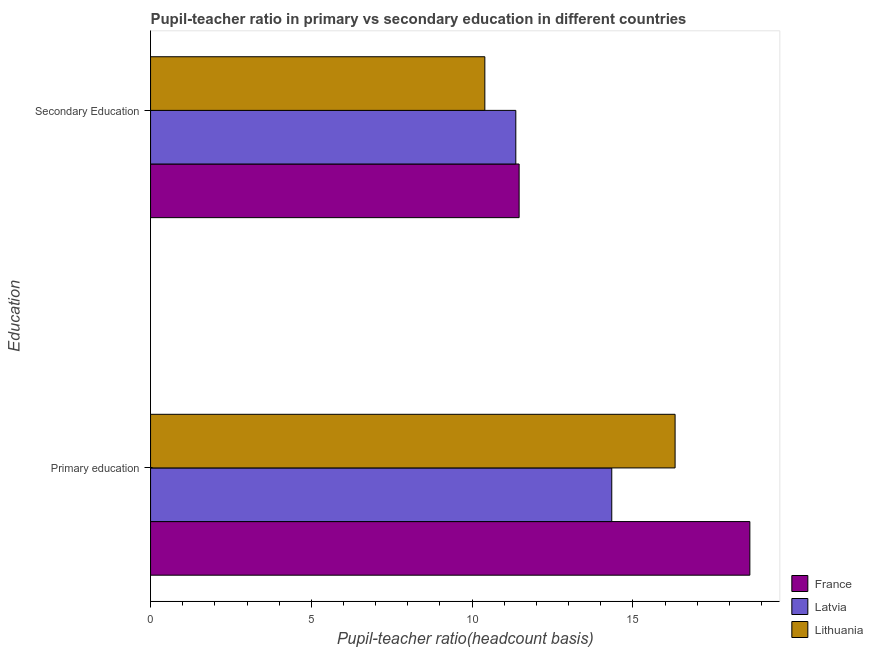How many different coloured bars are there?
Your answer should be compact. 3. Are the number of bars per tick equal to the number of legend labels?
Your answer should be compact. Yes. Are the number of bars on each tick of the Y-axis equal?
Your response must be concise. Yes. What is the label of the 1st group of bars from the top?
Provide a short and direct response. Secondary Education. What is the pupil-teacher ratio in primary education in France?
Offer a very short reply. 18.64. Across all countries, what is the maximum pupil-teacher ratio in primary education?
Provide a succinct answer. 18.64. Across all countries, what is the minimum pupil teacher ratio on secondary education?
Keep it short and to the point. 10.4. In which country was the pupil teacher ratio on secondary education maximum?
Keep it short and to the point. France. In which country was the pupil teacher ratio on secondary education minimum?
Your response must be concise. Lithuania. What is the total pupil-teacher ratio in primary education in the graph?
Your response must be concise. 49.3. What is the difference between the pupil-teacher ratio in primary education in France and that in Lithuania?
Give a very brief answer. 2.33. What is the difference between the pupil teacher ratio on secondary education in France and the pupil-teacher ratio in primary education in Lithuania?
Make the answer very short. -4.85. What is the average pupil-teacher ratio in primary education per country?
Your answer should be compact. 16.43. What is the difference between the pupil teacher ratio on secondary education and pupil-teacher ratio in primary education in Latvia?
Offer a very short reply. -2.98. In how many countries, is the pupil-teacher ratio in primary education greater than 4 ?
Offer a very short reply. 3. What is the ratio of the pupil-teacher ratio in primary education in Lithuania to that in Latvia?
Your response must be concise. 1.14. In how many countries, is the pupil-teacher ratio in primary education greater than the average pupil-teacher ratio in primary education taken over all countries?
Your response must be concise. 1. What does the 2nd bar from the top in Secondary Education represents?
Provide a short and direct response. Latvia. What does the 2nd bar from the bottom in Secondary Education represents?
Ensure brevity in your answer.  Latvia. How many bars are there?
Your answer should be compact. 6. What is the difference between two consecutive major ticks on the X-axis?
Your answer should be compact. 5. Are the values on the major ticks of X-axis written in scientific E-notation?
Provide a short and direct response. No. Does the graph contain grids?
Give a very brief answer. No. Where does the legend appear in the graph?
Ensure brevity in your answer.  Bottom right. What is the title of the graph?
Provide a succinct answer. Pupil-teacher ratio in primary vs secondary education in different countries. What is the label or title of the X-axis?
Ensure brevity in your answer.  Pupil-teacher ratio(headcount basis). What is the label or title of the Y-axis?
Make the answer very short. Education. What is the Pupil-teacher ratio(headcount basis) of France in Primary education?
Your answer should be compact. 18.64. What is the Pupil-teacher ratio(headcount basis) of Latvia in Primary education?
Keep it short and to the point. 14.34. What is the Pupil-teacher ratio(headcount basis) of Lithuania in Primary education?
Provide a succinct answer. 16.31. What is the Pupil-teacher ratio(headcount basis) in France in Secondary Education?
Your answer should be compact. 11.46. What is the Pupil-teacher ratio(headcount basis) of Latvia in Secondary Education?
Offer a very short reply. 11.36. What is the Pupil-teacher ratio(headcount basis) of Lithuania in Secondary Education?
Offer a very short reply. 10.4. Across all Education, what is the maximum Pupil-teacher ratio(headcount basis) of France?
Keep it short and to the point. 18.64. Across all Education, what is the maximum Pupil-teacher ratio(headcount basis) in Latvia?
Your answer should be compact. 14.34. Across all Education, what is the maximum Pupil-teacher ratio(headcount basis) of Lithuania?
Provide a short and direct response. 16.31. Across all Education, what is the minimum Pupil-teacher ratio(headcount basis) of France?
Your answer should be compact. 11.46. Across all Education, what is the minimum Pupil-teacher ratio(headcount basis) of Latvia?
Give a very brief answer. 11.36. Across all Education, what is the minimum Pupil-teacher ratio(headcount basis) in Lithuania?
Provide a short and direct response. 10.4. What is the total Pupil-teacher ratio(headcount basis) of France in the graph?
Make the answer very short. 30.1. What is the total Pupil-teacher ratio(headcount basis) of Latvia in the graph?
Offer a very short reply. 25.7. What is the total Pupil-teacher ratio(headcount basis) in Lithuania in the graph?
Give a very brief answer. 26.71. What is the difference between the Pupil-teacher ratio(headcount basis) in France in Primary education and that in Secondary Education?
Your answer should be compact. 7.18. What is the difference between the Pupil-teacher ratio(headcount basis) of Latvia in Primary education and that in Secondary Education?
Your response must be concise. 2.98. What is the difference between the Pupil-teacher ratio(headcount basis) in Lithuania in Primary education and that in Secondary Education?
Your answer should be compact. 5.92. What is the difference between the Pupil-teacher ratio(headcount basis) of France in Primary education and the Pupil-teacher ratio(headcount basis) of Latvia in Secondary Education?
Offer a terse response. 7.28. What is the difference between the Pupil-teacher ratio(headcount basis) in France in Primary education and the Pupil-teacher ratio(headcount basis) in Lithuania in Secondary Education?
Your answer should be very brief. 8.24. What is the difference between the Pupil-teacher ratio(headcount basis) in Latvia in Primary education and the Pupil-teacher ratio(headcount basis) in Lithuania in Secondary Education?
Offer a terse response. 3.95. What is the average Pupil-teacher ratio(headcount basis) in France per Education?
Provide a succinct answer. 15.05. What is the average Pupil-teacher ratio(headcount basis) in Latvia per Education?
Give a very brief answer. 12.85. What is the average Pupil-teacher ratio(headcount basis) in Lithuania per Education?
Your response must be concise. 13.36. What is the difference between the Pupil-teacher ratio(headcount basis) in France and Pupil-teacher ratio(headcount basis) in Latvia in Primary education?
Offer a very short reply. 4.29. What is the difference between the Pupil-teacher ratio(headcount basis) of France and Pupil-teacher ratio(headcount basis) of Lithuania in Primary education?
Your answer should be compact. 2.33. What is the difference between the Pupil-teacher ratio(headcount basis) in Latvia and Pupil-teacher ratio(headcount basis) in Lithuania in Primary education?
Offer a very short reply. -1.97. What is the difference between the Pupil-teacher ratio(headcount basis) of France and Pupil-teacher ratio(headcount basis) of Latvia in Secondary Education?
Your answer should be compact. 0.1. What is the difference between the Pupil-teacher ratio(headcount basis) of France and Pupil-teacher ratio(headcount basis) of Lithuania in Secondary Education?
Offer a very short reply. 1.07. What is the difference between the Pupil-teacher ratio(headcount basis) of Latvia and Pupil-teacher ratio(headcount basis) of Lithuania in Secondary Education?
Provide a short and direct response. 0.96. What is the ratio of the Pupil-teacher ratio(headcount basis) of France in Primary education to that in Secondary Education?
Make the answer very short. 1.63. What is the ratio of the Pupil-teacher ratio(headcount basis) of Latvia in Primary education to that in Secondary Education?
Offer a terse response. 1.26. What is the ratio of the Pupil-teacher ratio(headcount basis) of Lithuania in Primary education to that in Secondary Education?
Offer a very short reply. 1.57. What is the difference between the highest and the second highest Pupil-teacher ratio(headcount basis) of France?
Ensure brevity in your answer.  7.18. What is the difference between the highest and the second highest Pupil-teacher ratio(headcount basis) in Latvia?
Offer a very short reply. 2.98. What is the difference between the highest and the second highest Pupil-teacher ratio(headcount basis) in Lithuania?
Provide a succinct answer. 5.92. What is the difference between the highest and the lowest Pupil-teacher ratio(headcount basis) of France?
Provide a succinct answer. 7.18. What is the difference between the highest and the lowest Pupil-teacher ratio(headcount basis) in Latvia?
Your response must be concise. 2.98. What is the difference between the highest and the lowest Pupil-teacher ratio(headcount basis) in Lithuania?
Make the answer very short. 5.92. 